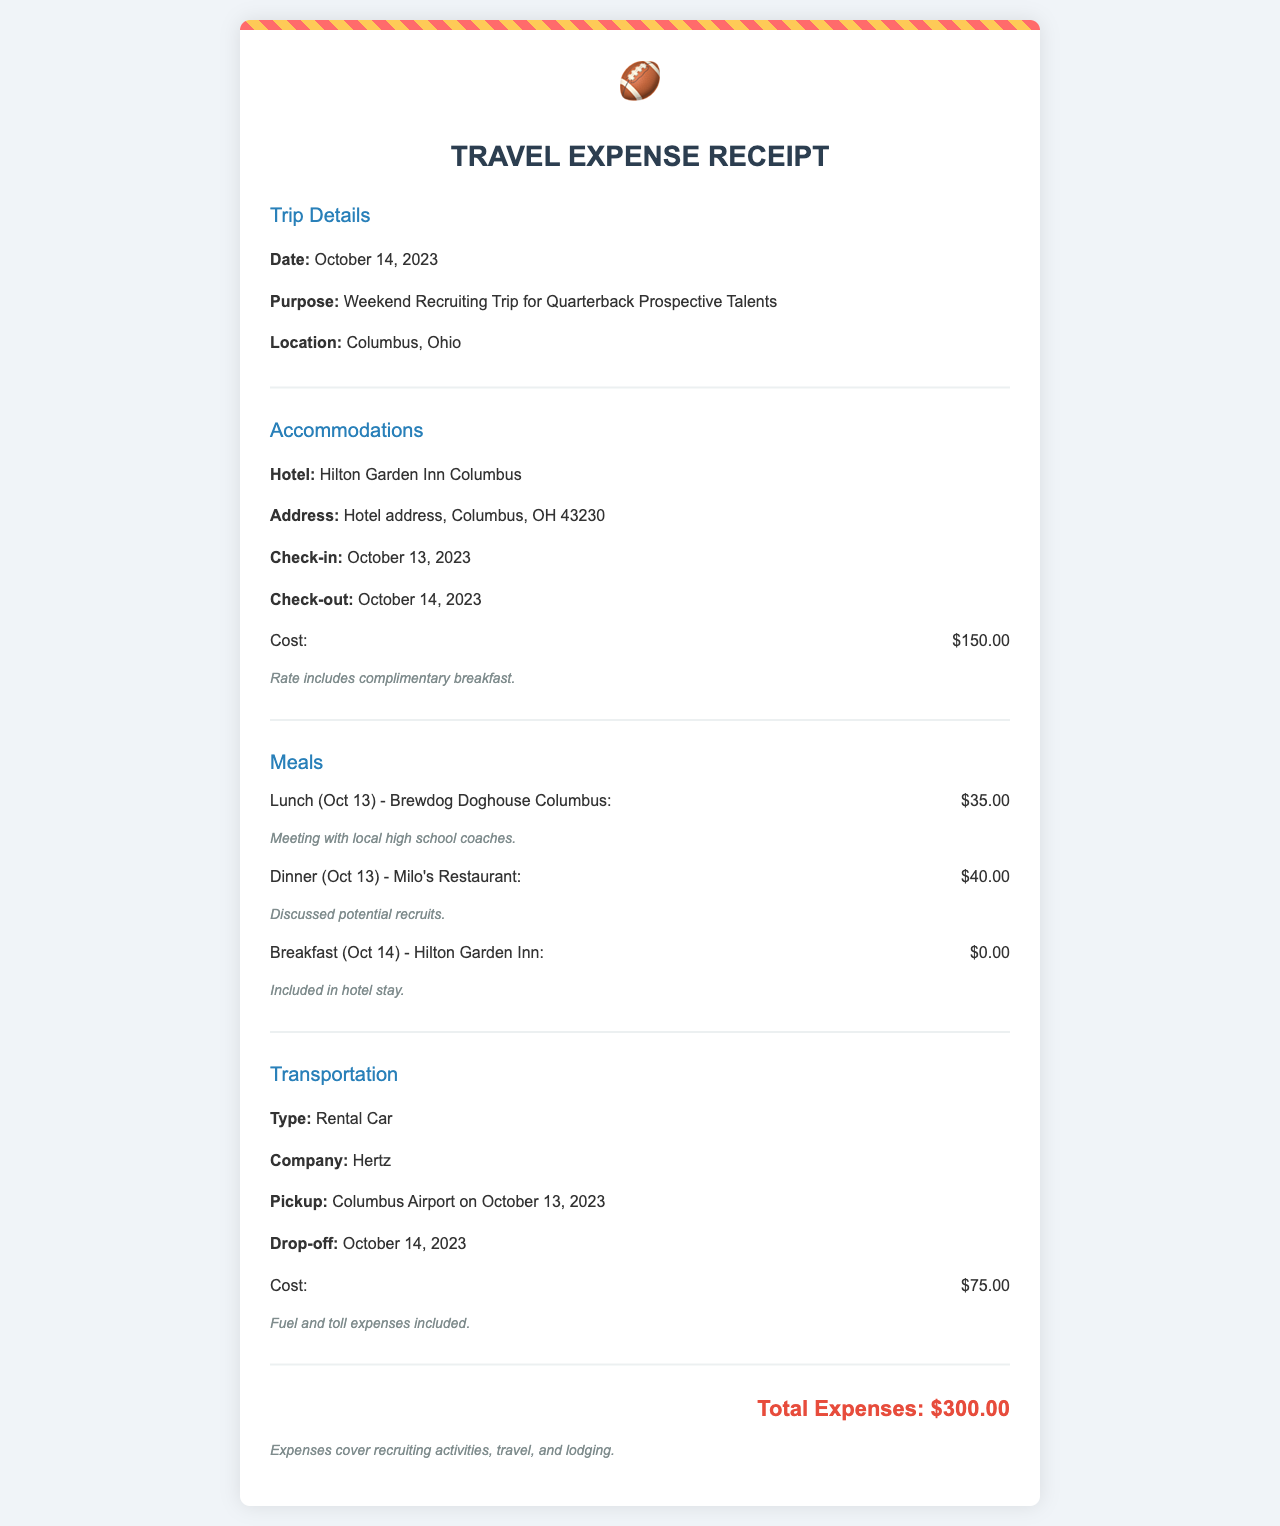What is the date of the trip? The date of the trip is specifically mentioned in the document, which states October 14, 2023.
Answer: October 14, 2023 Where was the recruiting trip located? The location of the recruiting trip is indicated in the document as Columbus, Ohio.
Answer: Columbus, Ohio What was the hotel used for accommodations? The document specifies the name of the hotel as Hilton Garden Inn Columbus.
Answer: Hilton Garden Inn Columbus What was the cost of the rental car? The rental car cost is explicitly stated in the transportation section of the document, which shows $75.00.
Answer: $75.00 What was the total expense for the trip? The total expenses are clearly summarized at the end of the document, showing $300.00.
Answer: $300.00 What meal was included in the hotel stay? The document notes that breakfast on October 14 is included in the hotel stay.
Answer: Breakfast What was the purpose of the trip? The purpose of the trip is stated clearly in the document as a Weekend Recruiting Trip for Quarterback Prospective Talents.
Answer: Weekend Recruiting Trip for Quarterback Prospective Talents How much was spent on lunch? The cost of lunch on October 13 specifically mentioned in the document is $35.00.
Answer: $35.00 What type of transportation was used? The transportation section of the document indicates that a rental car was used.
Answer: Rental Car 